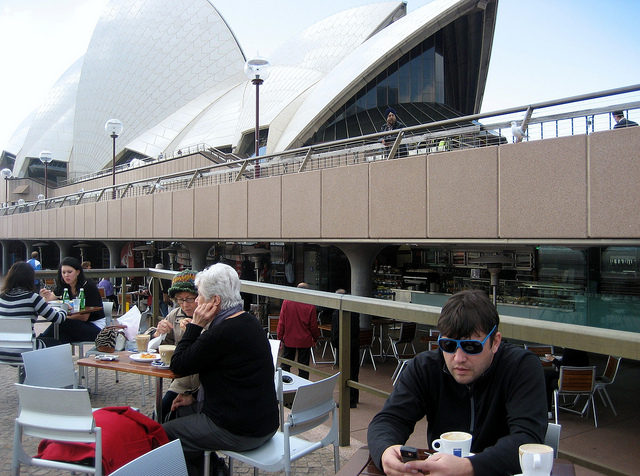<image>Is the man wearing a black shirt? I am unsure if the man is wearing a black shirt. Is the man wearing a black shirt? I am not sure if the man is wearing a black shirt. It is possible that he is, but I cannot say for certain. 